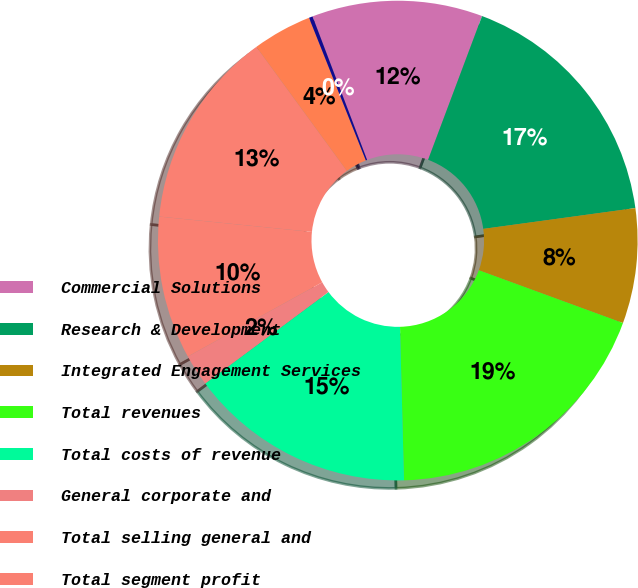Convert chart to OTSL. <chart><loc_0><loc_0><loc_500><loc_500><pie_chart><fcel>Commercial Solutions<fcel>Research & Development<fcel>Integrated Engagement Services<fcel>Total revenues<fcel>Total costs of revenue<fcel>General corporate and<fcel>Total selling general and<fcel>Total segment profit<fcel>Depreciation and amortization<fcel>Restructuring costs<nl><fcel>11.5%<fcel>17.12%<fcel>7.75%<fcel>19.0%<fcel>15.25%<fcel>2.13%<fcel>9.63%<fcel>13.37%<fcel>4.0%<fcel>0.25%<nl></chart> 